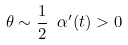<formula> <loc_0><loc_0><loc_500><loc_500>\theta \sim \frac { 1 } { 2 } \ \alpha { ^ { \prime } } ( t ) > 0</formula> 